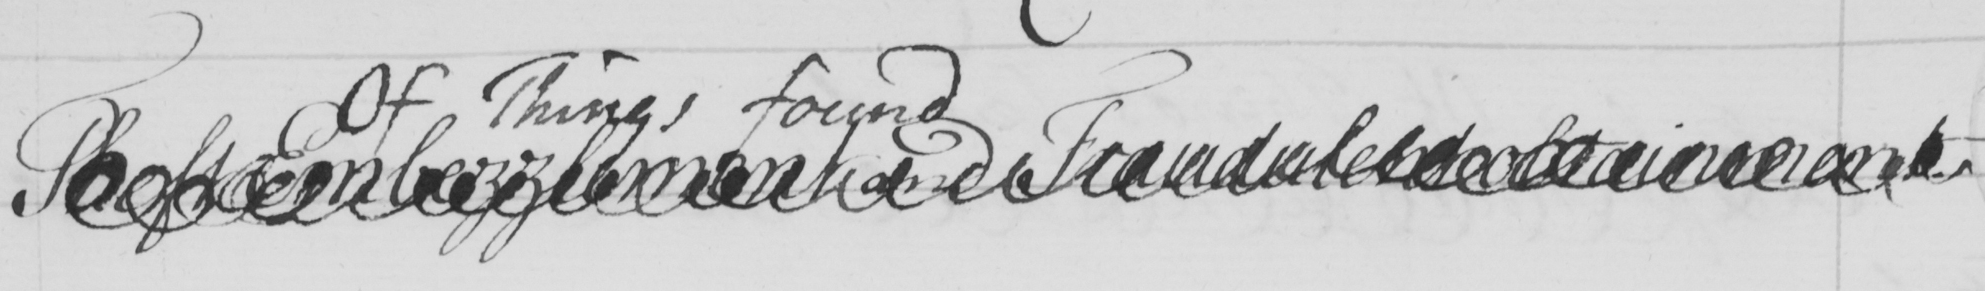Transcribe the text shown in this historical manuscript line. Theft Eembezzlement and Fraudulent obtainment 